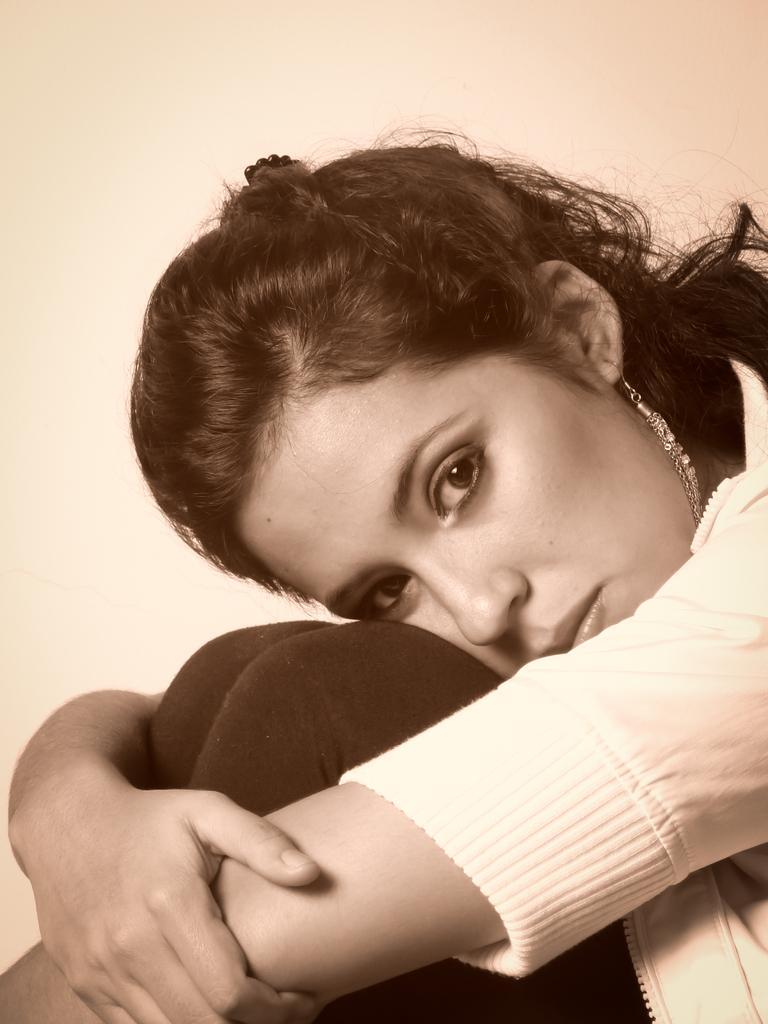Describe this image in one or two sentences. This is an edited image. In this image we can see a woman sitting. On the backside we can see a wall. 